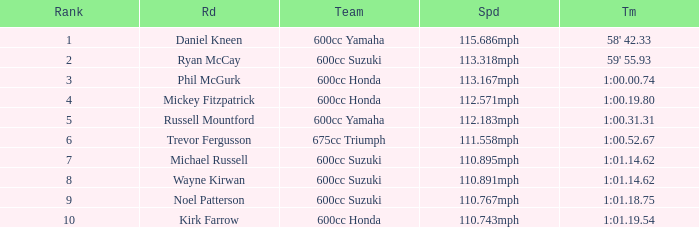How many ranks have 1:01.14.62 as the time, with michael russell as the rider? 1.0. 